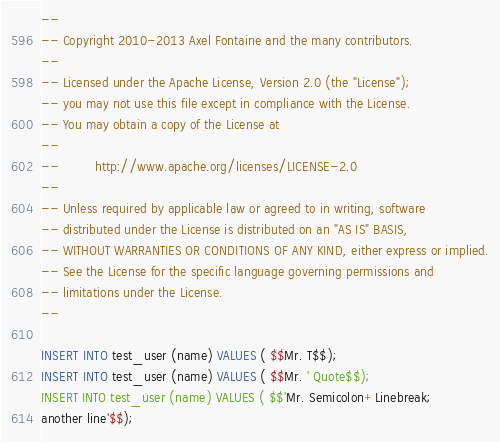Convert code to text. <code><loc_0><loc_0><loc_500><loc_500><_SQL_>--
-- Copyright 2010-2013 Axel Fontaine and the many contributors.
--
-- Licensed under the Apache License, Version 2.0 (the "License");
-- you may not use this file except in compliance with the License.
-- You may obtain a copy of the License at
--
--         http://www.apache.org/licenses/LICENSE-2.0
--
-- Unless required by applicable law or agreed to in writing, software
-- distributed under the License is distributed on an "AS IS" BASIS,
-- WITHOUT WARRANTIES OR CONDITIONS OF ANY KIND, either express or implied.
-- See the License for the specific language governing permissions and
-- limitations under the License.
--

INSERT INTO test_user (name) VALUES ( $$Mr. T$$);
INSERT INTO test_user (name) VALUES ( $$Mr. ' Quote$$);
INSERT INTO test_user (name) VALUES ( $$'Mr. Semicolon+Linebreak;
another line'$$);</code> 